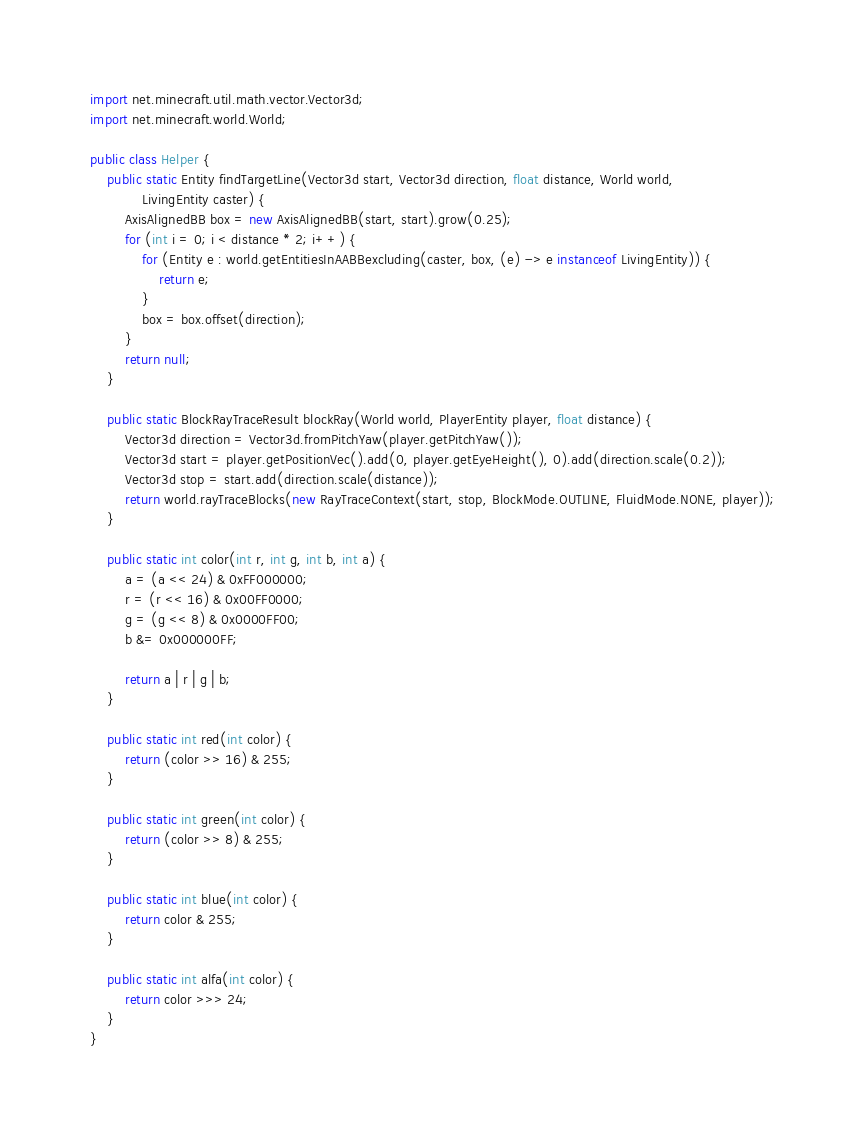Convert code to text. <code><loc_0><loc_0><loc_500><loc_500><_Java_>import net.minecraft.util.math.vector.Vector3d;
import net.minecraft.world.World;

public class Helper {
	public static Entity findTargetLine(Vector3d start, Vector3d direction, float distance, World world,
			LivingEntity caster) {
		AxisAlignedBB box = new AxisAlignedBB(start, start).grow(0.25);
		for (int i = 0; i < distance * 2; i++) {
			for (Entity e : world.getEntitiesInAABBexcluding(caster, box, (e) -> e instanceof LivingEntity)) {
				return e;
			}
			box = box.offset(direction);
		}
		return null;
	}

	public static BlockRayTraceResult blockRay(World world, PlayerEntity player, float distance) {
		Vector3d direction = Vector3d.fromPitchYaw(player.getPitchYaw());
		Vector3d start = player.getPositionVec().add(0, player.getEyeHeight(), 0).add(direction.scale(0.2));
		Vector3d stop = start.add(direction.scale(distance));
		return world.rayTraceBlocks(new RayTraceContext(start, stop, BlockMode.OUTLINE, FluidMode.NONE, player));
	}

	public static int color(int r, int g, int b, int a) {
		a = (a << 24) & 0xFF000000;
		r = (r << 16) & 0x00FF0000;
		g = (g << 8) & 0x0000FF00;
		b &= 0x000000FF;

		return a | r | g | b;
	}

	public static int red(int color) {
		return (color >> 16) & 255;
	}

	public static int green(int color) {
		return (color >> 8) & 255;
	}

	public static int blue(int color) {
		return color & 255;
	}

	public static int alfa(int color) {
		return color >>> 24;
	}
}
</code> 